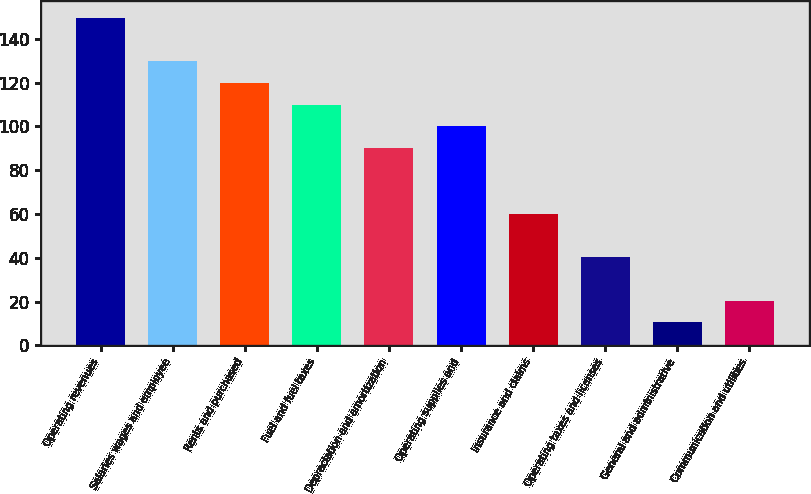Convert chart. <chart><loc_0><loc_0><loc_500><loc_500><bar_chart><fcel>Operating revenues<fcel>Salaries wages and employee<fcel>Rents and purchased<fcel>Fuel and fuel taxes<fcel>Depreciation and amortization<fcel>Operating supplies and<fcel>Insurance and claims<fcel>Operating taxes and licenses<fcel>General and administrative<fcel>Communication and utilities<nl><fcel>149.75<fcel>129.85<fcel>119.9<fcel>109.95<fcel>90.05<fcel>100<fcel>60.2<fcel>40.3<fcel>10.45<fcel>20.4<nl></chart> 